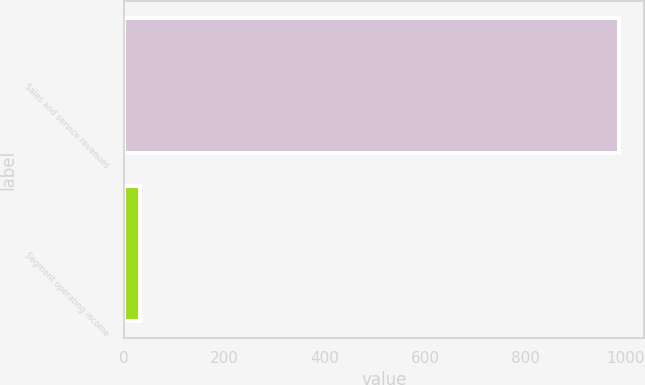<chart> <loc_0><loc_0><loc_500><loc_500><bar_chart><fcel>Sales and service revenues<fcel>Segment operating income<nl><fcel>988<fcel>32<nl></chart> 